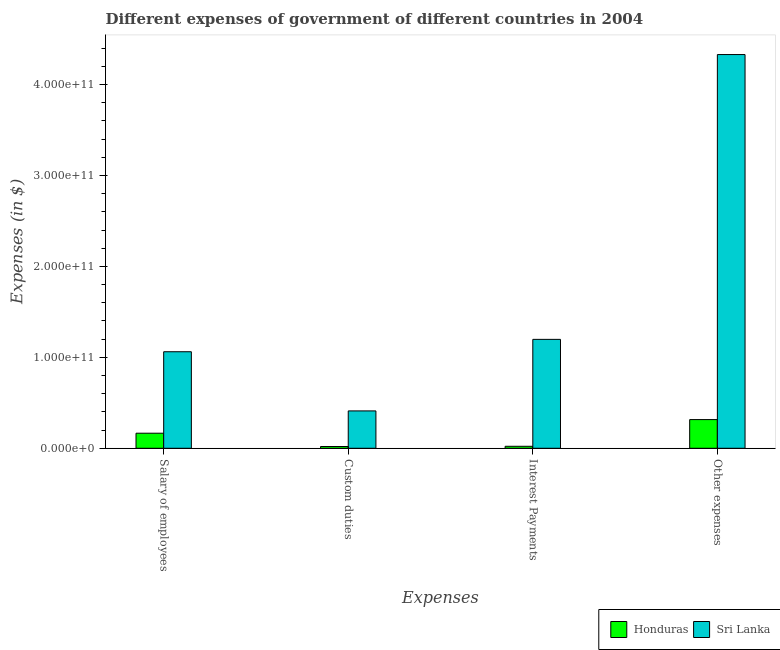How many different coloured bars are there?
Ensure brevity in your answer.  2. How many groups of bars are there?
Your answer should be very brief. 4. Are the number of bars per tick equal to the number of legend labels?
Provide a succinct answer. Yes. Are the number of bars on each tick of the X-axis equal?
Provide a short and direct response. Yes. How many bars are there on the 2nd tick from the left?
Provide a succinct answer. 2. What is the label of the 4th group of bars from the left?
Your response must be concise. Other expenses. What is the amount spent on interest payments in Honduras?
Your answer should be compact. 2.18e+09. Across all countries, what is the maximum amount spent on salary of employees?
Provide a succinct answer. 1.06e+11. Across all countries, what is the minimum amount spent on custom duties?
Make the answer very short. 1.95e+09. In which country was the amount spent on custom duties maximum?
Give a very brief answer. Sri Lanka. In which country was the amount spent on custom duties minimum?
Offer a very short reply. Honduras. What is the total amount spent on interest payments in the graph?
Your answer should be compact. 1.22e+11. What is the difference between the amount spent on interest payments in Sri Lanka and that in Honduras?
Give a very brief answer. 1.18e+11. What is the difference between the amount spent on salary of employees in Sri Lanka and the amount spent on custom duties in Honduras?
Give a very brief answer. 1.04e+11. What is the average amount spent on interest payments per country?
Your response must be concise. 6.10e+1. What is the difference between the amount spent on interest payments and amount spent on other expenses in Honduras?
Provide a succinct answer. -2.94e+1. In how many countries, is the amount spent on salary of employees greater than 280000000000 $?
Provide a short and direct response. 0. What is the ratio of the amount spent on salary of employees in Honduras to that in Sri Lanka?
Provide a succinct answer. 0.16. Is the amount spent on salary of employees in Honduras less than that in Sri Lanka?
Give a very brief answer. Yes. Is the difference between the amount spent on custom duties in Honduras and Sri Lanka greater than the difference between the amount spent on interest payments in Honduras and Sri Lanka?
Your answer should be compact. Yes. What is the difference between the highest and the second highest amount spent on interest payments?
Offer a very short reply. 1.18e+11. What is the difference between the highest and the lowest amount spent on custom duties?
Offer a very short reply. 3.91e+1. Is the sum of the amount spent on custom duties in Sri Lanka and Honduras greater than the maximum amount spent on salary of employees across all countries?
Ensure brevity in your answer.  No. Is it the case that in every country, the sum of the amount spent on custom duties and amount spent on interest payments is greater than the sum of amount spent on other expenses and amount spent on salary of employees?
Your response must be concise. No. What does the 1st bar from the left in Interest Payments represents?
Make the answer very short. Honduras. What does the 1st bar from the right in Other expenses represents?
Make the answer very short. Sri Lanka. Is it the case that in every country, the sum of the amount spent on salary of employees and amount spent on custom duties is greater than the amount spent on interest payments?
Give a very brief answer. Yes. Are all the bars in the graph horizontal?
Keep it short and to the point. No. How many countries are there in the graph?
Keep it short and to the point. 2. What is the difference between two consecutive major ticks on the Y-axis?
Your answer should be compact. 1.00e+11. Does the graph contain any zero values?
Offer a terse response. No. How many legend labels are there?
Keep it short and to the point. 2. How are the legend labels stacked?
Ensure brevity in your answer.  Horizontal. What is the title of the graph?
Give a very brief answer. Different expenses of government of different countries in 2004. What is the label or title of the X-axis?
Provide a short and direct response. Expenses. What is the label or title of the Y-axis?
Your answer should be very brief. Expenses (in $). What is the Expenses (in $) of Honduras in Salary of employees?
Make the answer very short. 1.66e+1. What is the Expenses (in $) in Sri Lanka in Salary of employees?
Provide a short and direct response. 1.06e+11. What is the Expenses (in $) in Honduras in Custom duties?
Keep it short and to the point. 1.95e+09. What is the Expenses (in $) in Sri Lanka in Custom duties?
Your response must be concise. 4.11e+1. What is the Expenses (in $) in Honduras in Interest Payments?
Provide a short and direct response. 2.18e+09. What is the Expenses (in $) of Sri Lanka in Interest Payments?
Offer a very short reply. 1.20e+11. What is the Expenses (in $) of Honduras in Other expenses?
Ensure brevity in your answer.  3.16e+1. What is the Expenses (in $) in Sri Lanka in Other expenses?
Your answer should be compact. 4.33e+11. Across all Expenses, what is the maximum Expenses (in $) in Honduras?
Make the answer very short. 3.16e+1. Across all Expenses, what is the maximum Expenses (in $) of Sri Lanka?
Your response must be concise. 4.33e+11. Across all Expenses, what is the minimum Expenses (in $) of Honduras?
Provide a short and direct response. 1.95e+09. Across all Expenses, what is the minimum Expenses (in $) in Sri Lanka?
Ensure brevity in your answer.  4.11e+1. What is the total Expenses (in $) in Honduras in the graph?
Offer a terse response. 5.23e+1. What is the total Expenses (in $) in Sri Lanka in the graph?
Provide a short and direct response. 7.00e+11. What is the difference between the Expenses (in $) in Honduras in Salary of employees and that in Custom duties?
Your response must be concise. 1.46e+1. What is the difference between the Expenses (in $) in Sri Lanka in Salary of employees and that in Custom duties?
Ensure brevity in your answer.  6.51e+1. What is the difference between the Expenses (in $) in Honduras in Salary of employees and that in Interest Payments?
Give a very brief answer. 1.44e+1. What is the difference between the Expenses (in $) in Sri Lanka in Salary of employees and that in Interest Payments?
Give a very brief answer. -1.36e+1. What is the difference between the Expenses (in $) of Honduras in Salary of employees and that in Other expenses?
Your response must be concise. -1.50e+1. What is the difference between the Expenses (in $) of Sri Lanka in Salary of employees and that in Other expenses?
Give a very brief answer. -3.27e+11. What is the difference between the Expenses (in $) of Honduras in Custom duties and that in Interest Payments?
Give a very brief answer. -2.32e+08. What is the difference between the Expenses (in $) in Sri Lanka in Custom duties and that in Interest Payments?
Make the answer very short. -7.87e+1. What is the difference between the Expenses (in $) in Honduras in Custom duties and that in Other expenses?
Provide a succinct answer. -2.96e+1. What is the difference between the Expenses (in $) in Sri Lanka in Custom duties and that in Other expenses?
Your answer should be very brief. -3.92e+11. What is the difference between the Expenses (in $) in Honduras in Interest Payments and that in Other expenses?
Provide a succinct answer. -2.94e+1. What is the difference between the Expenses (in $) in Sri Lanka in Interest Payments and that in Other expenses?
Your answer should be very brief. -3.13e+11. What is the difference between the Expenses (in $) of Honduras in Salary of employees and the Expenses (in $) of Sri Lanka in Custom duties?
Your answer should be compact. -2.45e+1. What is the difference between the Expenses (in $) in Honduras in Salary of employees and the Expenses (in $) in Sri Lanka in Interest Payments?
Keep it short and to the point. -1.03e+11. What is the difference between the Expenses (in $) of Honduras in Salary of employees and the Expenses (in $) of Sri Lanka in Other expenses?
Give a very brief answer. -4.16e+11. What is the difference between the Expenses (in $) in Honduras in Custom duties and the Expenses (in $) in Sri Lanka in Interest Payments?
Make the answer very short. -1.18e+11. What is the difference between the Expenses (in $) of Honduras in Custom duties and the Expenses (in $) of Sri Lanka in Other expenses?
Your response must be concise. -4.31e+11. What is the difference between the Expenses (in $) in Honduras in Interest Payments and the Expenses (in $) in Sri Lanka in Other expenses?
Your answer should be compact. -4.31e+11. What is the average Expenses (in $) of Honduras per Expenses?
Your answer should be compact. 1.31e+1. What is the average Expenses (in $) in Sri Lanka per Expenses?
Provide a short and direct response. 1.75e+11. What is the difference between the Expenses (in $) of Honduras and Expenses (in $) of Sri Lanka in Salary of employees?
Keep it short and to the point. -8.96e+1. What is the difference between the Expenses (in $) of Honduras and Expenses (in $) of Sri Lanka in Custom duties?
Offer a terse response. -3.91e+1. What is the difference between the Expenses (in $) of Honduras and Expenses (in $) of Sri Lanka in Interest Payments?
Keep it short and to the point. -1.18e+11. What is the difference between the Expenses (in $) in Honduras and Expenses (in $) in Sri Lanka in Other expenses?
Make the answer very short. -4.01e+11. What is the ratio of the Expenses (in $) of Honduras in Salary of employees to that in Custom duties?
Your response must be concise. 8.49. What is the ratio of the Expenses (in $) of Sri Lanka in Salary of employees to that in Custom duties?
Offer a terse response. 2.58. What is the ratio of the Expenses (in $) of Honduras in Salary of employees to that in Interest Payments?
Keep it short and to the point. 7.59. What is the ratio of the Expenses (in $) of Sri Lanka in Salary of employees to that in Interest Payments?
Ensure brevity in your answer.  0.89. What is the ratio of the Expenses (in $) in Honduras in Salary of employees to that in Other expenses?
Make the answer very short. 0.53. What is the ratio of the Expenses (in $) of Sri Lanka in Salary of employees to that in Other expenses?
Your answer should be very brief. 0.25. What is the ratio of the Expenses (in $) in Honduras in Custom duties to that in Interest Payments?
Provide a succinct answer. 0.89. What is the ratio of the Expenses (in $) of Sri Lanka in Custom duties to that in Interest Payments?
Your answer should be very brief. 0.34. What is the ratio of the Expenses (in $) in Honduras in Custom duties to that in Other expenses?
Offer a very short reply. 0.06. What is the ratio of the Expenses (in $) in Sri Lanka in Custom duties to that in Other expenses?
Make the answer very short. 0.09. What is the ratio of the Expenses (in $) of Honduras in Interest Payments to that in Other expenses?
Provide a short and direct response. 0.07. What is the ratio of the Expenses (in $) in Sri Lanka in Interest Payments to that in Other expenses?
Offer a terse response. 0.28. What is the difference between the highest and the second highest Expenses (in $) of Honduras?
Your response must be concise. 1.50e+1. What is the difference between the highest and the second highest Expenses (in $) in Sri Lanka?
Provide a short and direct response. 3.13e+11. What is the difference between the highest and the lowest Expenses (in $) in Honduras?
Ensure brevity in your answer.  2.96e+1. What is the difference between the highest and the lowest Expenses (in $) in Sri Lanka?
Offer a terse response. 3.92e+11. 